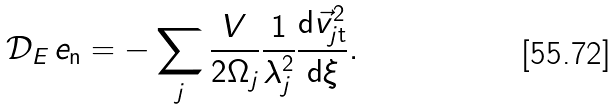Convert formula to latex. <formula><loc_0><loc_0><loc_500><loc_500>\mathcal { D } _ { E } \, e _ { \mathrm n } = - \sum _ { j } \frac { V } { 2 \Omega _ { j } } \frac { 1 } { \lambda _ { j } ^ { 2 } } \frac { \mathrm d \vec { v } _ { j \mathrm t } ^ { 2 } } { \mathrm d \xi } .</formula> 